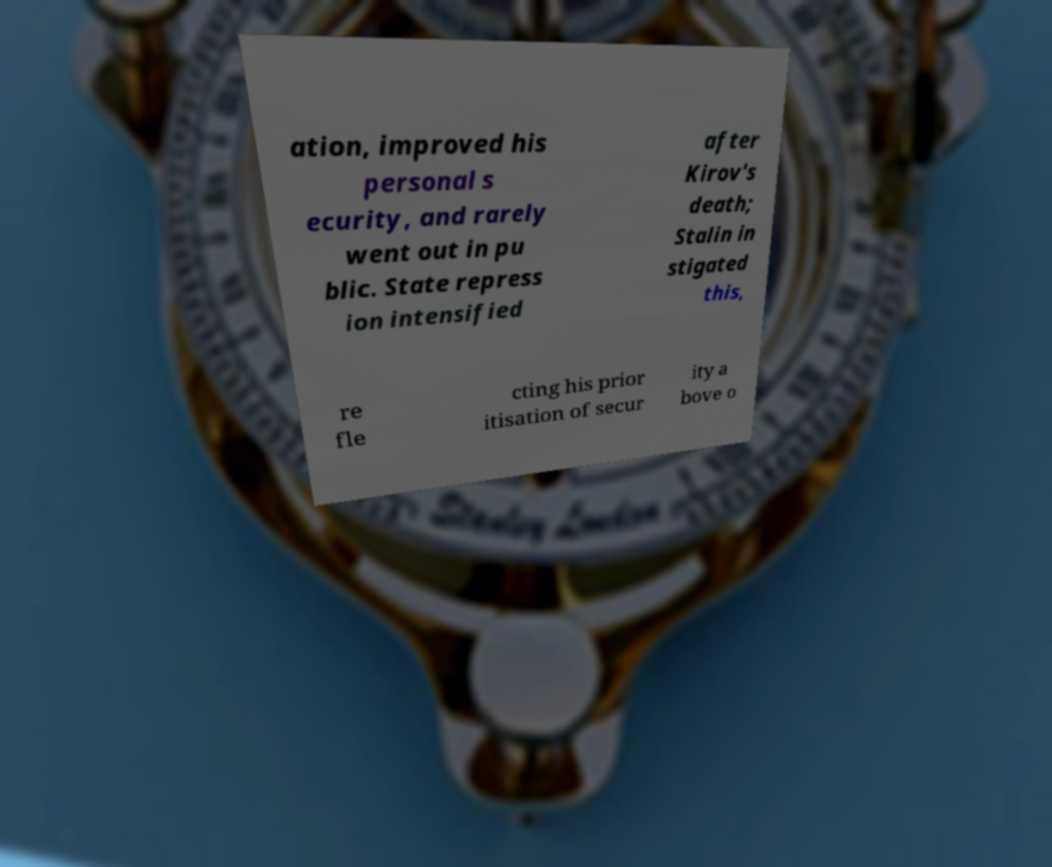There's text embedded in this image that I need extracted. Can you transcribe it verbatim? ation, improved his personal s ecurity, and rarely went out in pu blic. State repress ion intensified after Kirov's death; Stalin in stigated this, re fle cting his prior itisation of secur ity a bove o 